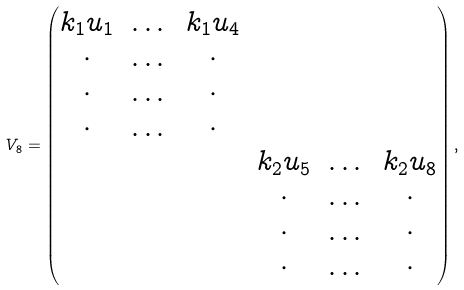Convert formula to latex. <formula><loc_0><loc_0><loc_500><loc_500>V _ { 8 } = \left ( \begin{matrix} \begin{matrix} k _ { 1 } u _ { 1 } & \dots & k _ { 1 } u _ { 4 } \\ \cdot & \dots & \cdot \\ \cdot & \dots & \cdot \\ \cdot & \dots & \cdot \end{matrix} & \\ & \begin{matrix} k _ { 2 } u _ { 5 } & \dots & k _ { 2 } u _ { 8 } \\ \cdot & \dots & \cdot \\ \cdot & \dots & \cdot \\ \cdot & \dots & \cdot \end{matrix} \end{matrix} \right ) ,</formula> 